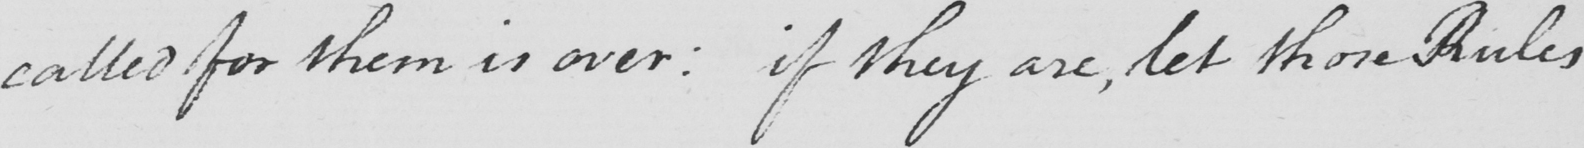Please provide the text content of this handwritten line. called fpr them is over :  if they are , let those Rules 